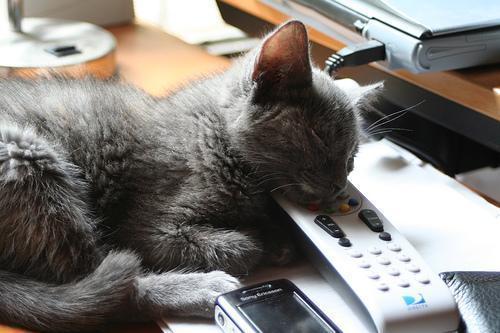How many phones are in the picture?
Give a very brief answer. 1. 